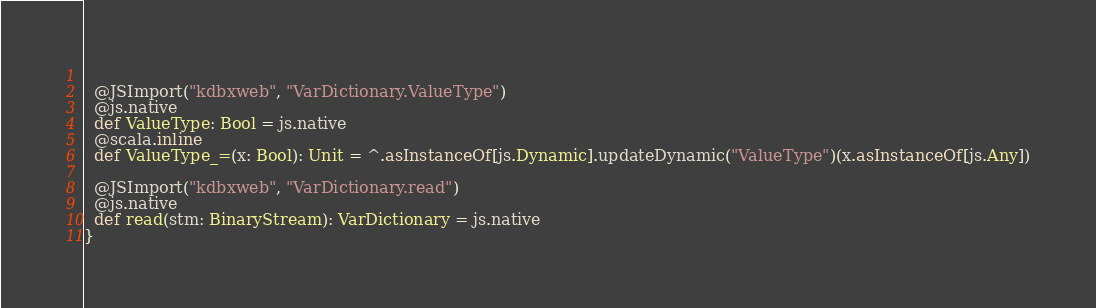<code> <loc_0><loc_0><loc_500><loc_500><_Scala_>  
  @JSImport("kdbxweb", "VarDictionary.ValueType")
  @js.native
  def ValueType: Bool = js.native
  @scala.inline
  def ValueType_=(x: Bool): Unit = ^.asInstanceOf[js.Dynamic].updateDynamic("ValueType")(x.asInstanceOf[js.Any])
  
  @JSImport("kdbxweb", "VarDictionary.read")
  @js.native
  def read(stm: BinaryStream): VarDictionary = js.native
}
</code> 